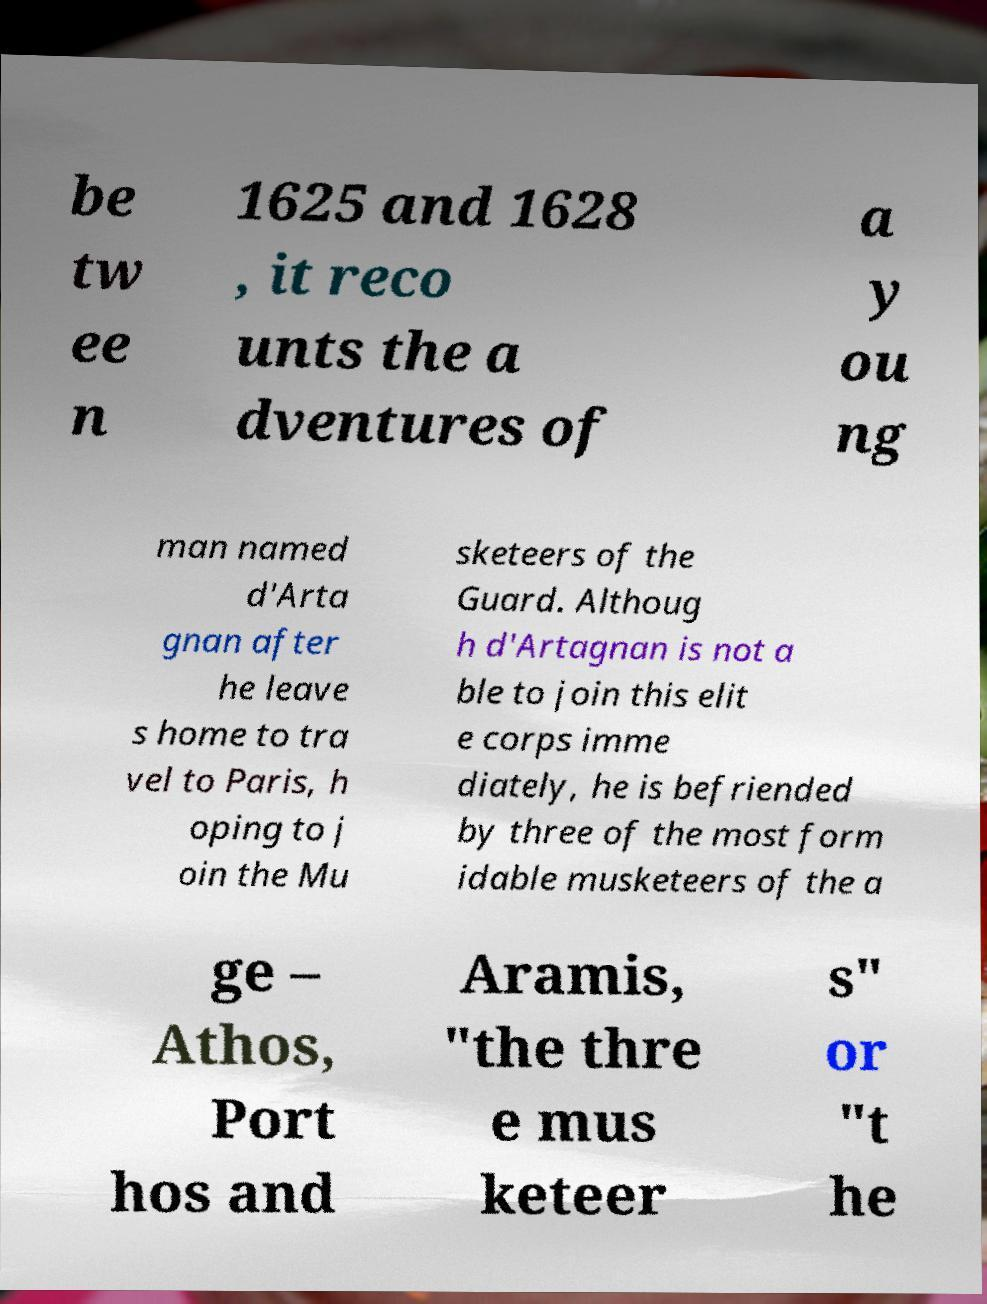Can you accurately transcribe the text from the provided image for me? be tw ee n 1625 and 1628 , it reco unts the a dventures of a y ou ng man named d'Arta gnan after he leave s home to tra vel to Paris, h oping to j oin the Mu sketeers of the Guard. Althoug h d'Artagnan is not a ble to join this elit e corps imme diately, he is befriended by three of the most form idable musketeers of the a ge – Athos, Port hos and Aramis, "the thre e mus keteer s" or "t he 